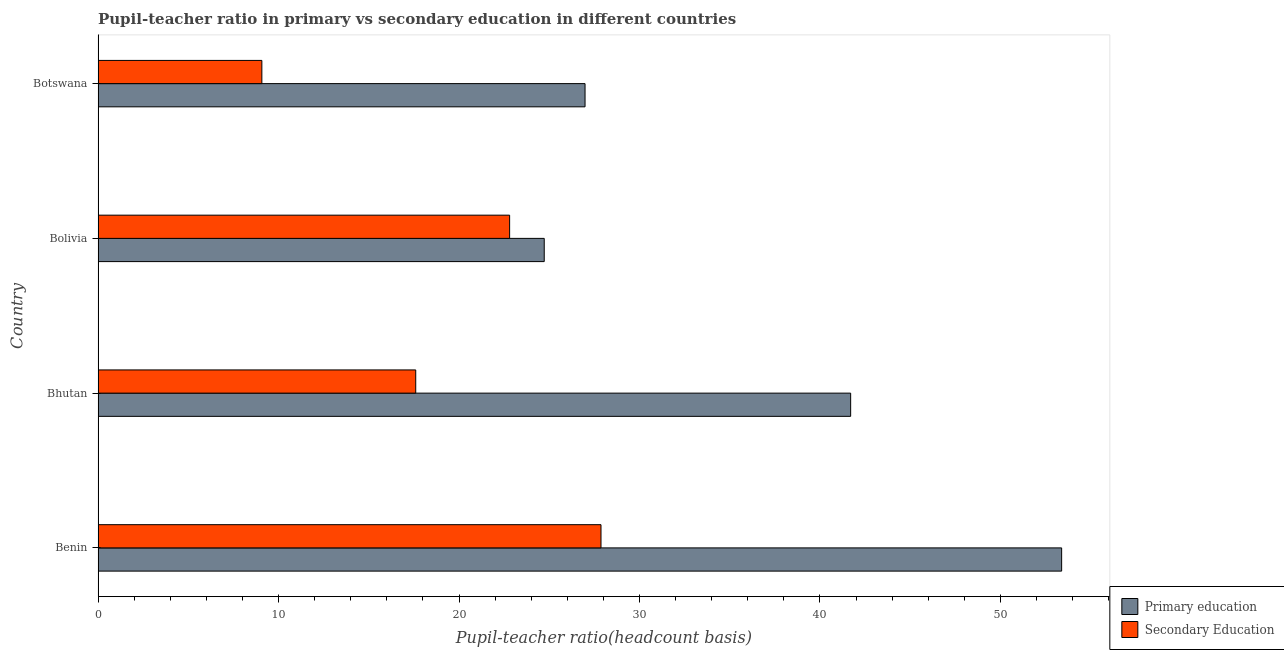How many different coloured bars are there?
Offer a terse response. 2. Are the number of bars on each tick of the Y-axis equal?
Ensure brevity in your answer.  Yes. How many bars are there on the 3rd tick from the top?
Your answer should be compact. 2. How many bars are there on the 3rd tick from the bottom?
Offer a very short reply. 2. What is the label of the 4th group of bars from the top?
Offer a terse response. Benin. What is the pupil teacher ratio on secondary education in Bhutan?
Ensure brevity in your answer.  17.6. Across all countries, what is the maximum pupil-teacher ratio in primary education?
Your answer should be compact. 53.4. Across all countries, what is the minimum pupil-teacher ratio in primary education?
Keep it short and to the point. 24.72. In which country was the pupil teacher ratio on secondary education maximum?
Offer a terse response. Benin. In which country was the pupil teacher ratio on secondary education minimum?
Offer a terse response. Botswana. What is the total pupil teacher ratio on secondary education in the graph?
Keep it short and to the point. 77.35. What is the difference between the pupil teacher ratio on secondary education in Bolivia and that in Botswana?
Make the answer very short. 13.73. What is the difference between the pupil teacher ratio on secondary education in Bhutan and the pupil-teacher ratio in primary education in Benin?
Your answer should be compact. -35.79. What is the average pupil-teacher ratio in primary education per country?
Offer a very short reply. 36.7. What is the difference between the pupil-teacher ratio in primary education and pupil teacher ratio on secondary education in Benin?
Ensure brevity in your answer.  25.53. What is the ratio of the pupil teacher ratio on secondary education in Benin to that in Bhutan?
Make the answer very short. 1.58. What is the difference between the highest and the second highest pupil teacher ratio on secondary education?
Keep it short and to the point. 5.06. What is the difference between the highest and the lowest pupil-teacher ratio in primary education?
Offer a terse response. 28.67. In how many countries, is the pupil teacher ratio on secondary education greater than the average pupil teacher ratio on secondary education taken over all countries?
Keep it short and to the point. 2. Is the sum of the pupil-teacher ratio in primary education in Benin and Bolivia greater than the maximum pupil teacher ratio on secondary education across all countries?
Provide a succinct answer. Yes. What does the 1st bar from the top in Botswana represents?
Make the answer very short. Secondary Education. Are all the bars in the graph horizontal?
Make the answer very short. Yes. How many countries are there in the graph?
Offer a very short reply. 4. Does the graph contain any zero values?
Your answer should be compact. No. Where does the legend appear in the graph?
Give a very brief answer. Bottom right. How are the legend labels stacked?
Give a very brief answer. Vertical. What is the title of the graph?
Provide a short and direct response. Pupil-teacher ratio in primary vs secondary education in different countries. Does "Boys" appear as one of the legend labels in the graph?
Offer a terse response. No. What is the label or title of the X-axis?
Give a very brief answer. Pupil-teacher ratio(headcount basis). What is the label or title of the Y-axis?
Ensure brevity in your answer.  Country. What is the Pupil-teacher ratio(headcount basis) in Primary education in Benin?
Give a very brief answer. 53.4. What is the Pupil-teacher ratio(headcount basis) of Secondary Education in Benin?
Provide a short and direct response. 27.87. What is the Pupil-teacher ratio(headcount basis) of Primary education in Bhutan?
Provide a succinct answer. 41.7. What is the Pupil-teacher ratio(headcount basis) of Secondary Education in Bhutan?
Your response must be concise. 17.6. What is the Pupil-teacher ratio(headcount basis) of Primary education in Bolivia?
Provide a short and direct response. 24.72. What is the Pupil-teacher ratio(headcount basis) of Secondary Education in Bolivia?
Offer a terse response. 22.81. What is the Pupil-teacher ratio(headcount basis) in Primary education in Botswana?
Make the answer very short. 26.99. What is the Pupil-teacher ratio(headcount basis) of Secondary Education in Botswana?
Provide a succinct answer. 9.08. Across all countries, what is the maximum Pupil-teacher ratio(headcount basis) of Primary education?
Offer a very short reply. 53.4. Across all countries, what is the maximum Pupil-teacher ratio(headcount basis) in Secondary Education?
Your response must be concise. 27.87. Across all countries, what is the minimum Pupil-teacher ratio(headcount basis) of Primary education?
Your answer should be compact. 24.72. Across all countries, what is the minimum Pupil-teacher ratio(headcount basis) of Secondary Education?
Provide a succinct answer. 9.08. What is the total Pupil-teacher ratio(headcount basis) of Primary education in the graph?
Your answer should be very brief. 146.81. What is the total Pupil-teacher ratio(headcount basis) in Secondary Education in the graph?
Your answer should be compact. 77.35. What is the difference between the Pupil-teacher ratio(headcount basis) in Primary education in Benin and that in Bhutan?
Provide a succinct answer. 11.69. What is the difference between the Pupil-teacher ratio(headcount basis) of Secondary Education in Benin and that in Bhutan?
Ensure brevity in your answer.  10.27. What is the difference between the Pupil-teacher ratio(headcount basis) in Primary education in Benin and that in Bolivia?
Your response must be concise. 28.67. What is the difference between the Pupil-teacher ratio(headcount basis) of Secondary Education in Benin and that in Bolivia?
Ensure brevity in your answer.  5.06. What is the difference between the Pupil-teacher ratio(headcount basis) of Primary education in Benin and that in Botswana?
Offer a terse response. 26.41. What is the difference between the Pupil-teacher ratio(headcount basis) in Secondary Education in Benin and that in Botswana?
Your answer should be compact. 18.79. What is the difference between the Pupil-teacher ratio(headcount basis) in Primary education in Bhutan and that in Bolivia?
Make the answer very short. 16.98. What is the difference between the Pupil-teacher ratio(headcount basis) of Secondary Education in Bhutan and that in Bolivia?
Give a very brief answer. -5.2. What is the difference between the Pupil-teacher ratio(headcount basis) in Primary education in Bhutan and that in Botswana?
Offer a very short reply. 14.72. What is the difference between the Pupil-teacher ratio(headcount basis) in Secondary Education in Bhutan and that in Botswana?
Give a very brief answer. 8.53. What is the difference between the Pupil-teacher ratio(headcount basis) in Primary education in Bolivia and that in Botswana?
Provide a short and direct response. -2.26. What is the difference between the Pupil-teacher ratio(headcount basis) of Secondary Education in Bolivia and that in Botswana?
Provide a succinct answer. 13.73. What is the difference between the Pupil-teacher ratio(headcount basis) in Primary education in Benin and the Pupil-teacher ratio(headcount basis) in Secondary Education in Bhutan?
Your answer should be compact. 35.79. What is the difference between the Pupil-teacher ratio(headcount basis) in Primary education in Benin and the Pupil-teacher ratio(headcount basis) in Secondary Education in Bolivia?
Offer a very short reply. 30.59. What is the difference between the Pupil-teacher ratio(headcount basis) in Primary education in Benin and the Pupil-teacher ratio(headcount basis) in Secondary Education in Botswana?
Your answer should be compact. 44.32. What is the difference between the Pupil-teacher ratio(headcount basis) of Primary education in Bhutan and the Pupil-teacher ratio(headcount basis) of Secondary Education in Bolivia?
Your answer should be very brief. 18.9. What is the difference between the Pupil-teacher ratio(headcount basis) of Primary education in Bhutan and the Pupil-teacher ratio(headcount basis) of Secondary Education in Botswana?
Your answer should be compact. 32.63. What is the difference between the Pupil-teacher ratio(headcount basis) of Primary education in Bolivia and the Pupil-teacher ratio(headcount basis) of Secondary Education in Botswana?
Ensure brevity in your answer.  15.65. What is the average Pupil-teacher ratio(headcount basis) of Primary education per country?
Provide a short and direct response. 36.7. What is the average Pupil-teacher ratio(headcount basis) in Secondary Education per country?
Offer a terse response. 19.34. What is the difference between the Pupil-teacher ratio(headcount basis) in Primary education and Pupil-teacher ratio(headcount basis) in Secondary Education in Benin?
Offer a very short reply. 25.53. What is the difference between the Pupil-teacher ratio(headcount basis) in Primary education and Pupil-teacher ratio(headcount basis) in Secondary Education in Bhutan?
Your response must be concise. 24.1. What is the difference between the Pupil-teacher ratio(headcount basis) in Primary education and Pupil-teacher ratio(headcount basis) in Secondary Education in Bolivia?
Provide a short and direct response. 1.92. What is the difference between the Pupil-teacher ratio(headcount basis) in Primary education and Pupil-teacher ratio(headcount basis) in Secondary Education in Botswana?
Provide a short and direct response. 17.91. What is the ratio of the Pupil-teacher ratio(headcount basis) of Primary education in Benin to that in Bhutan?
Provide a succinct answer. 1.28. What is the ratio of the Pupil-teacher ratio(headcount basis) of Secondary Education in Benin to that in Bhutan?
Ensure brevity in your answer.  1.58. What is the ratio of the Pupil-teacher ratio(headcount basis) in Primary education in Benin to that in Bolivia?
Ensure brevity in your answer.  2.16. What is the ratio of the Pupil-teacher ratio(headcount basis) in Secondary Education in Benin to that in Bolivia?
Your answer should be very brief. 1.22. What is the ratio of the Pupil-teacher ratio(headcount basis) of Primary education in Benin to that in Botswana?
Give a very brief answer. 1.98. What is the ratio of the Pupil-teacher ratio(headcount basis) of Secondary Education in Benin to that in Botswana?
Provide a succinct answer. 3.07. What is the ratio of the Pupil-teacher ratio(headcount basis) of Primary education in Bhutan to that in Bolivia?
Make the answer very short. 1.69. What is the ratio of the Pupil-teacher ratio(headcount basis) of Secondary Education in Bhutan to that in Bolivia?
Give a very brief answer. 0.77. What is the ratio of the Pupil-teacher ratio(headcount basis) in Primary education in Bhutan to that in Botswana?
Your answer should be compact. 1.55. What is the ratio of the Pupil-teacher ratio(headcount basis) in Secondary Education in Bhutan to that in Botswana?
Keep it short and to the point. 1.94. What is the ratio of the Pupil-teacher ratio(headcount basis) of Primary education in Bolivia to that in Botswana?
Offer a terse response. 0.92. What is the ratio of the Pupil-teacher ratio(headcount basis) in Secondary Education in Bolivia to that in Botswana?
Provide a short and direct response. 2.51. What is the difference between the highest and the second highest Pupil-teacher ratio(headcount basis) of Primary education?
Provide a short and direct response. 11.69. What is the difference between the highest and the second highest Pupil-teacher ratio(headcount basis) of Secondary Education?
Keep it short and to the point. 5.06. What is the difference between the highest and the lowest Pupil-teacher ratio(headcount basis) of Primary education?
Your answer should be very brief. 28.67. What is the difference between the highest and the lowest Pupil-teacher ratio(headcount basis) of Secondary Education?
Make the answer very short. 18.79. 